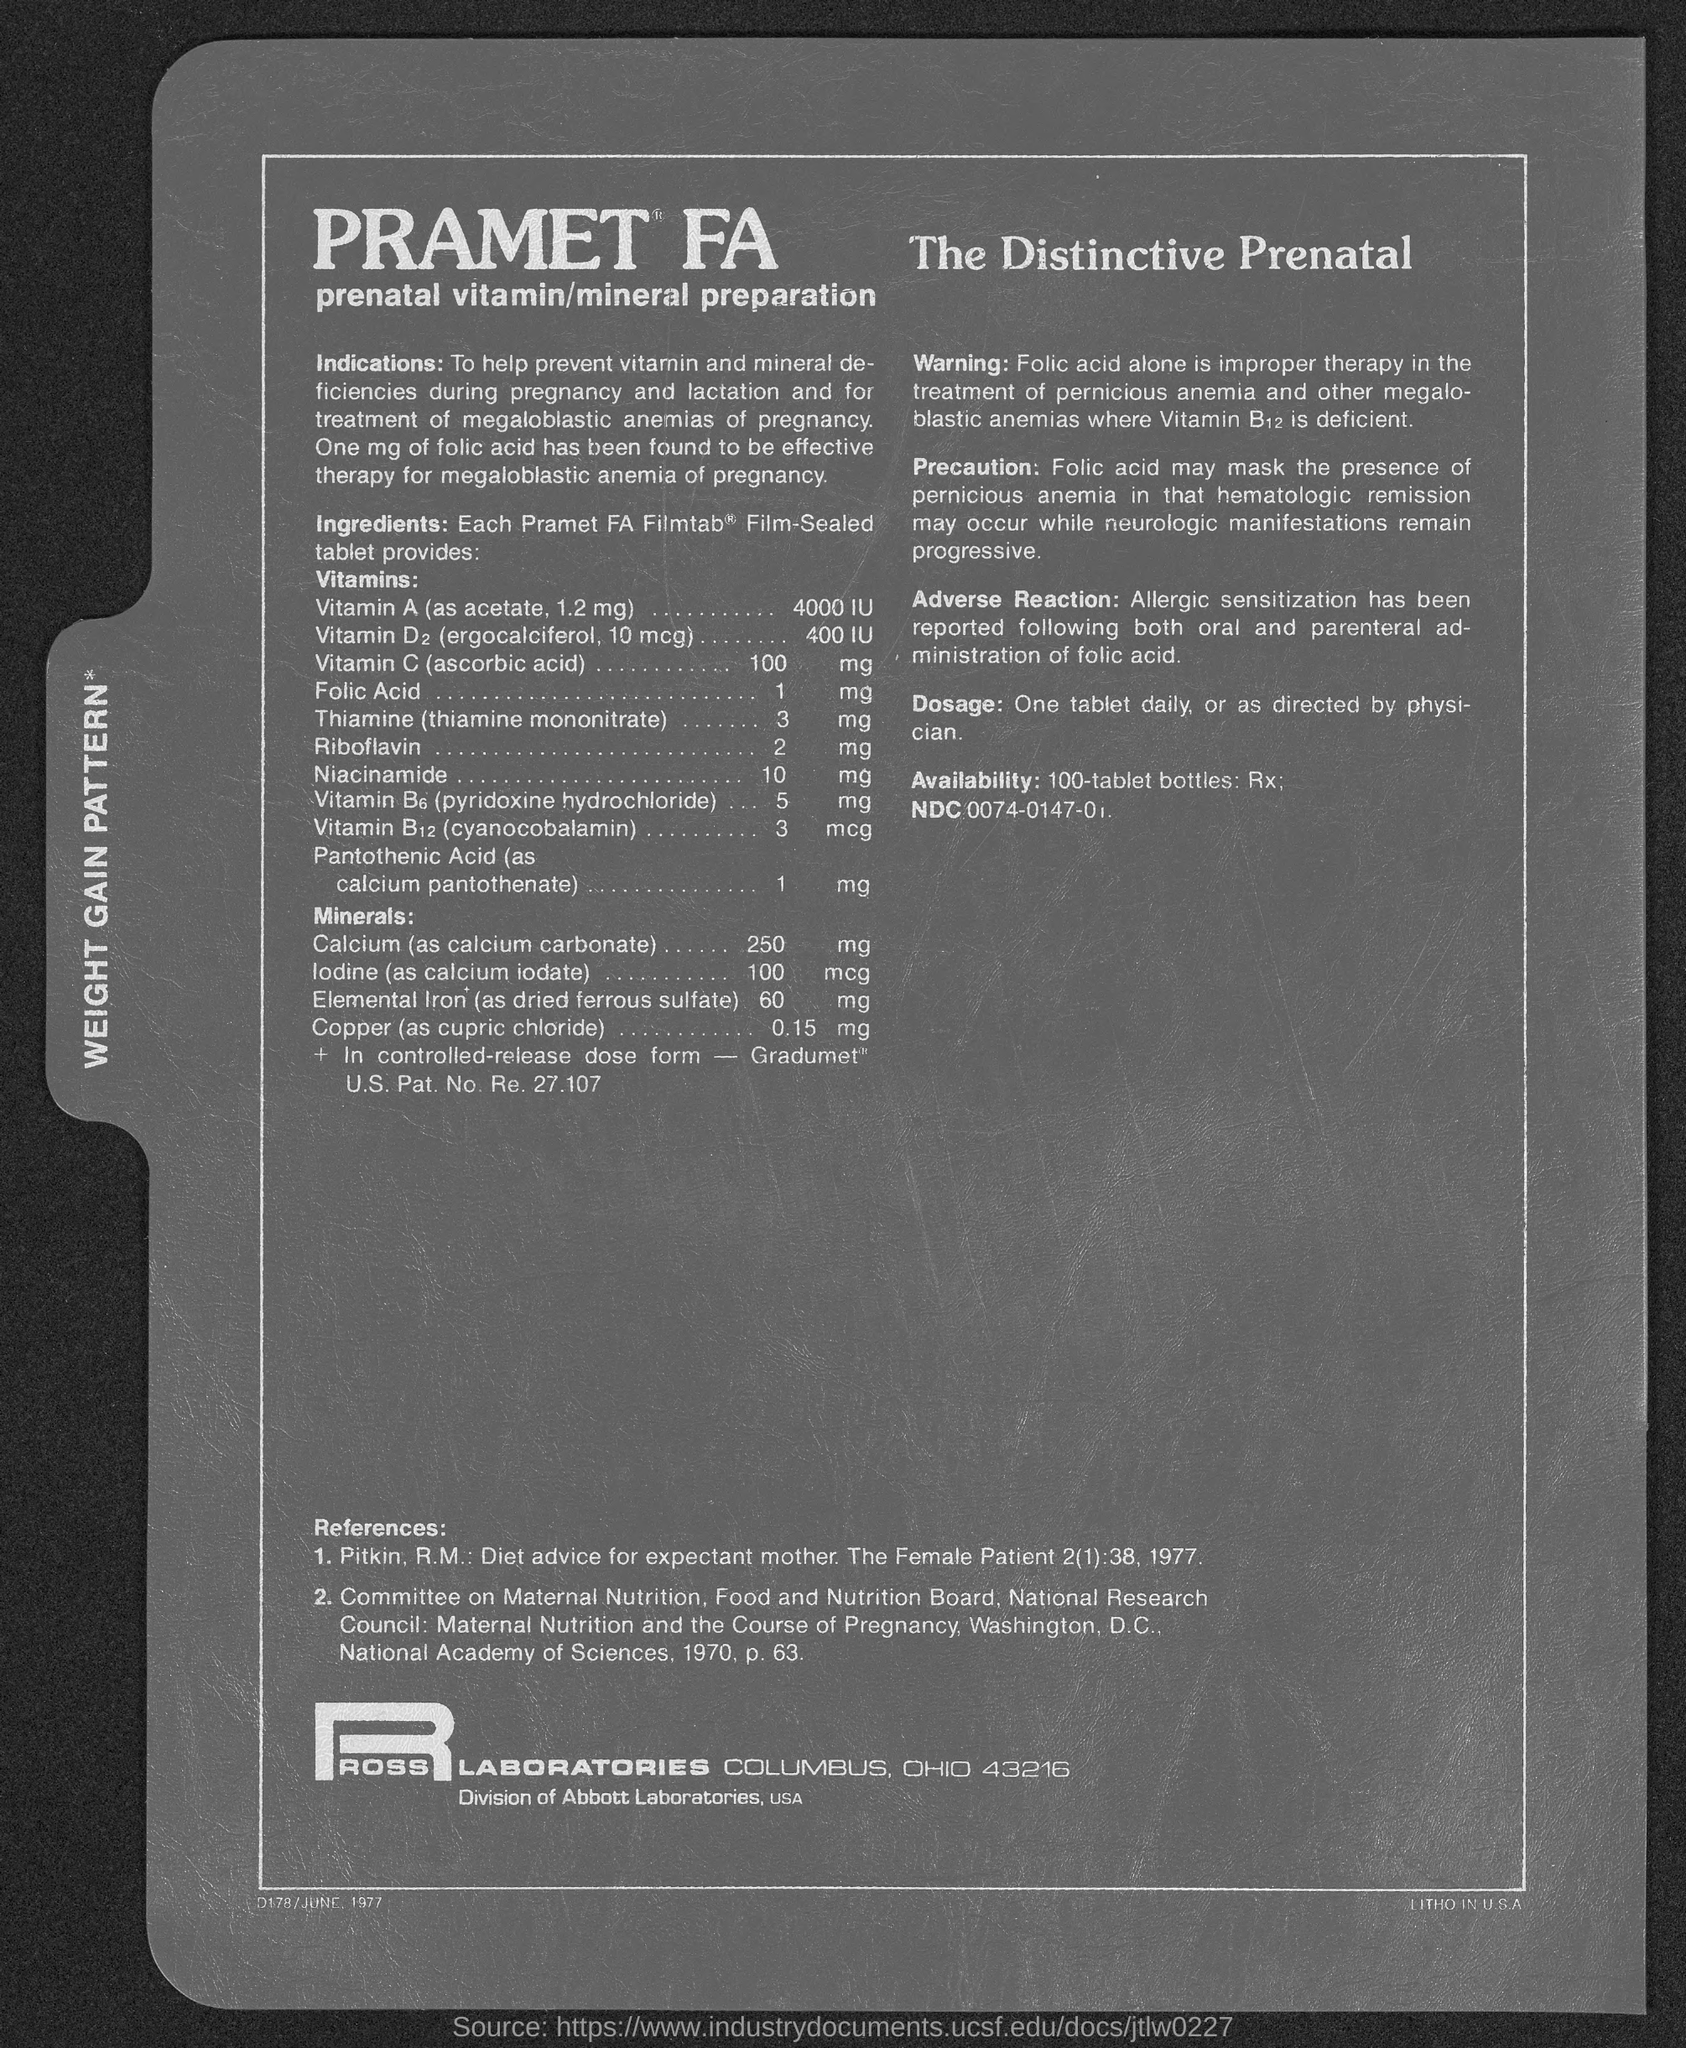In which city is ross laboratories at?
Make the answer very short. Columbus, Ohio 43216. 